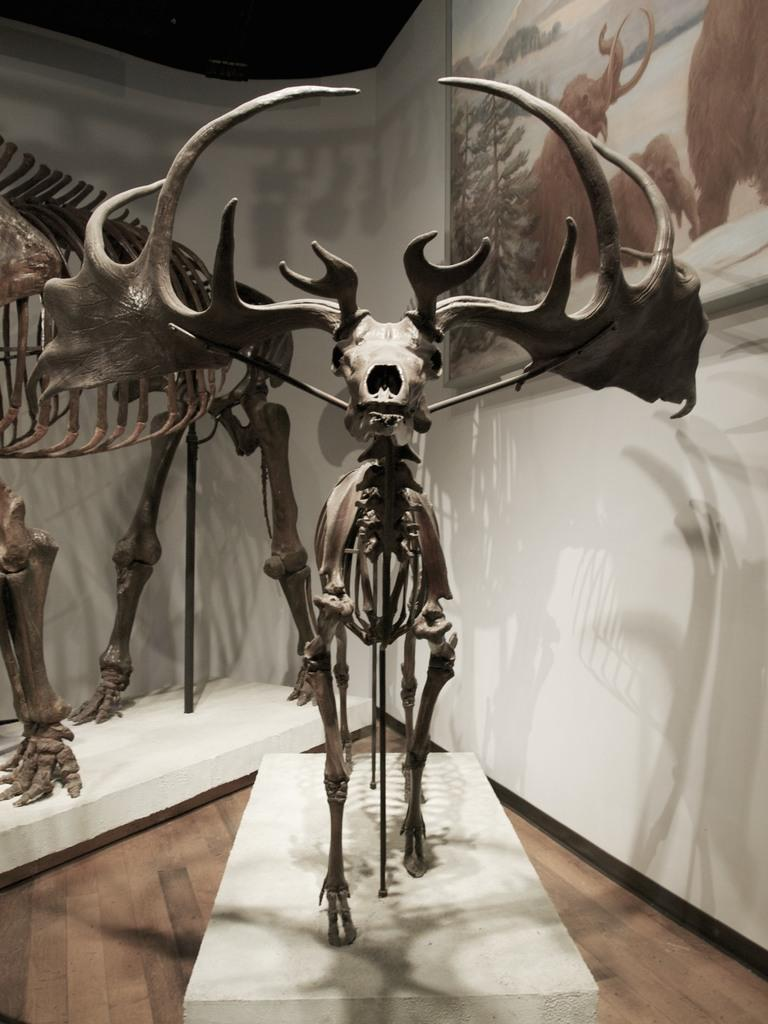What type of objects are present in the image? The image contains skeletons of animals. What is the surface on which the skeletons are placed? There is a floor at the bottom of the image. What can be seen in the background of the image? There is a wall in the background of the image. Is there any additional feature on the wall? Yes, a frame is fixed on the wall in the background. What type of cattle can be seen grazing in the image? There are no cattle present in the image; it contains skeletons of animals. How many trains are visible in the image? There are no trains visible in the image. 